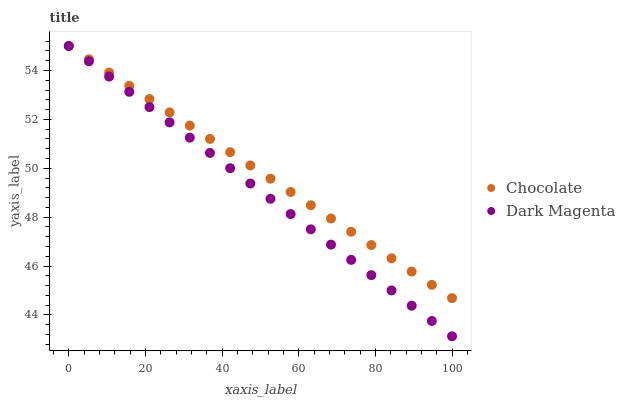Does Dark Magenta have the minimum area under the curve?
Answer yes or no. Yes. Does Chocolate have the maximum area under the curve?
Answer yes or no. Yes. Does Chocolate have the minimum area under the curve?
Answer yes or no. No. Is Chocolate the smoothest?
Answer yes or no. Yes. Is Dark Magenta the roughest?
Answer yes or no. Yes. Is Chocolate the roughest?
Answer yes or no. No. Does Dark Magenta have the lowest value?
Answer yes or no. Yes. Does Chocolate have the lowest value?
Answer yes or no. No. Does Chocolate have the highest value?
Answer yes or no. Yes. Does Chocolate intersect Dark Magenta?
Answer yes or no. Yes. Is Chocolate less than Dark Magenta?
Answer yes or no. No. Is Chocolate greater than Dark Magenta?
Answer yes or no. No. 